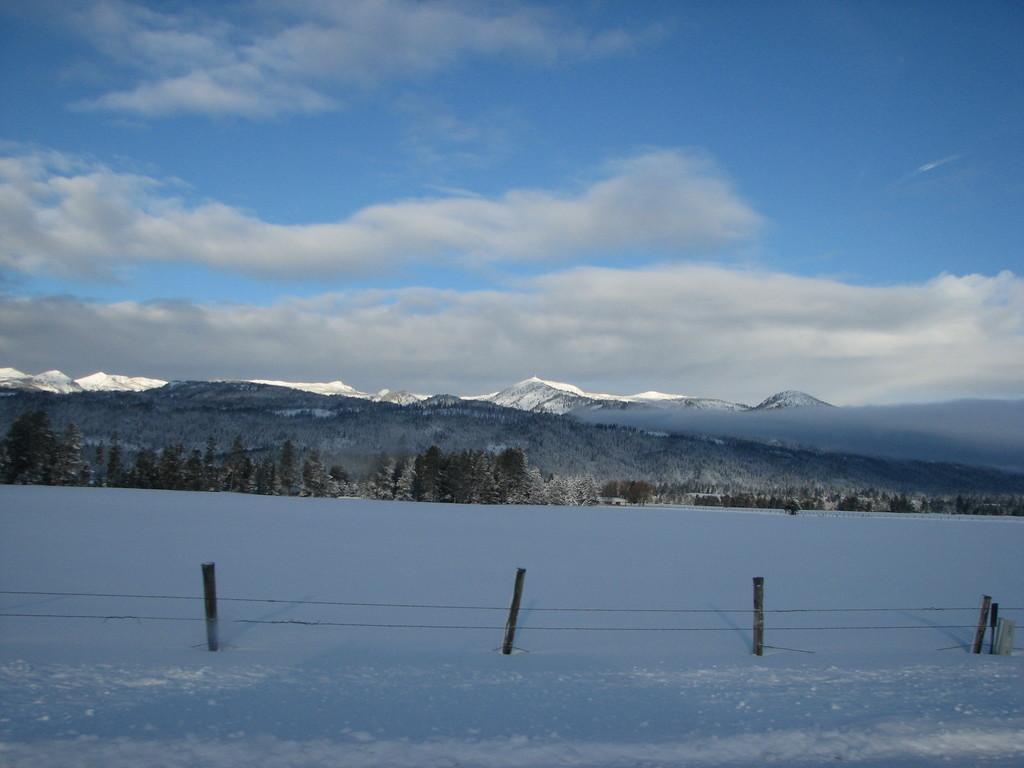Describe this image in one or two sentences. In this image there is a snow ground in the bottom of this image and there are some trees in the background. There are some mountains in middle of this image and there is a cloudy sky on the top of this image. 